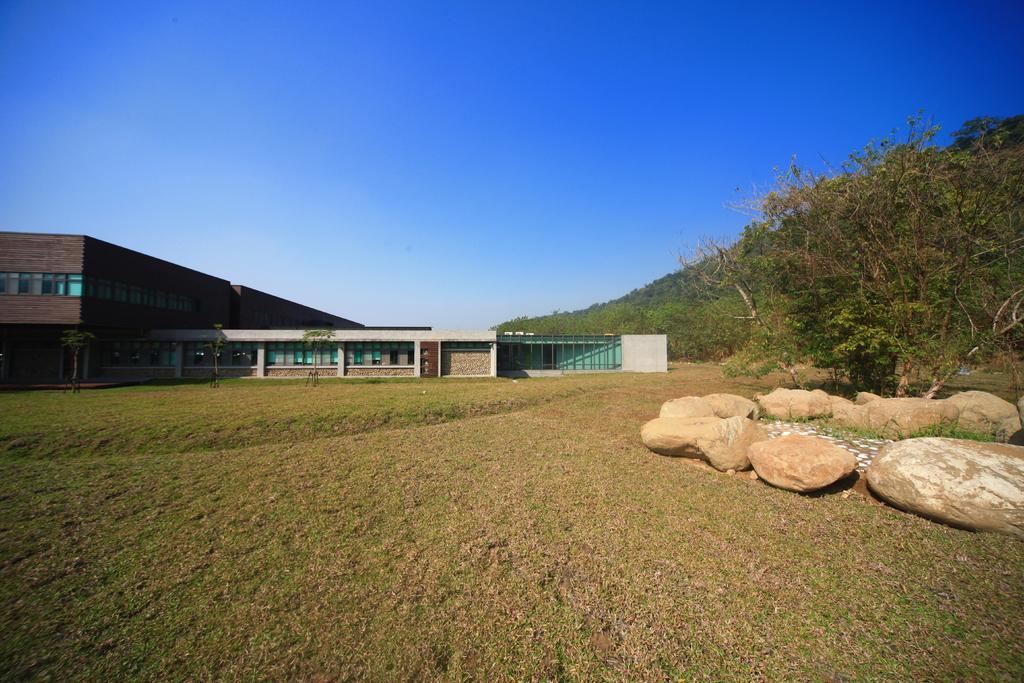Could you give a brief overview of what you see in this image? In this image we can see grass on the ground. On the right side there are rocks. Also there are trees. In the back there are buildings. In the background there is sky. 